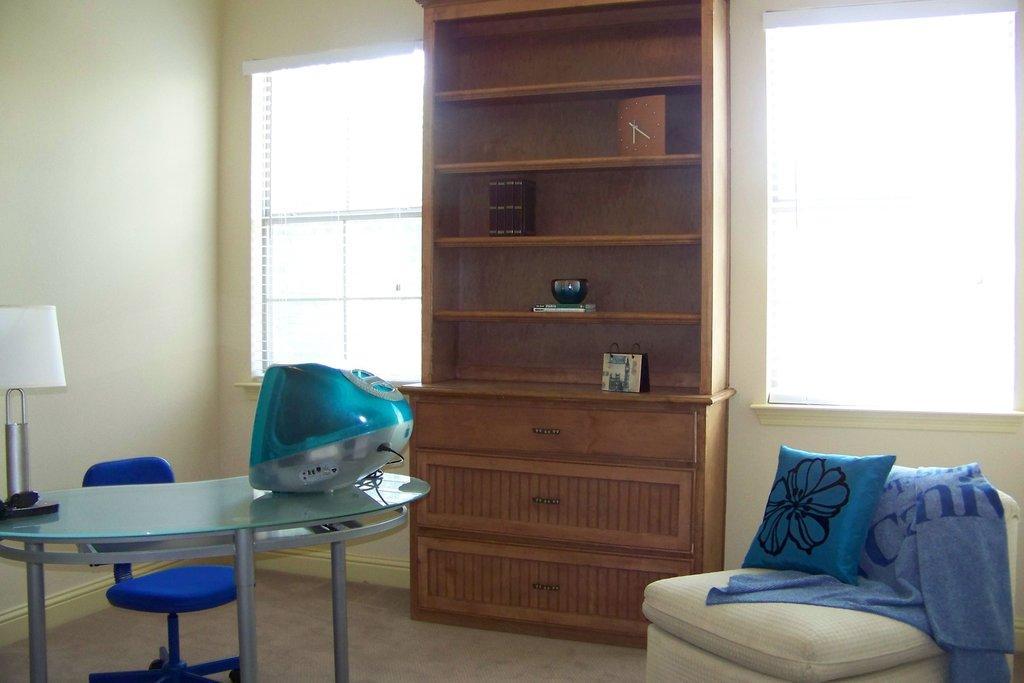Please provide a concise description of this image. On the table there is television,lamp and near chair is there,here there is sofa,cloth and shelf. here there are windows,this is wall. 